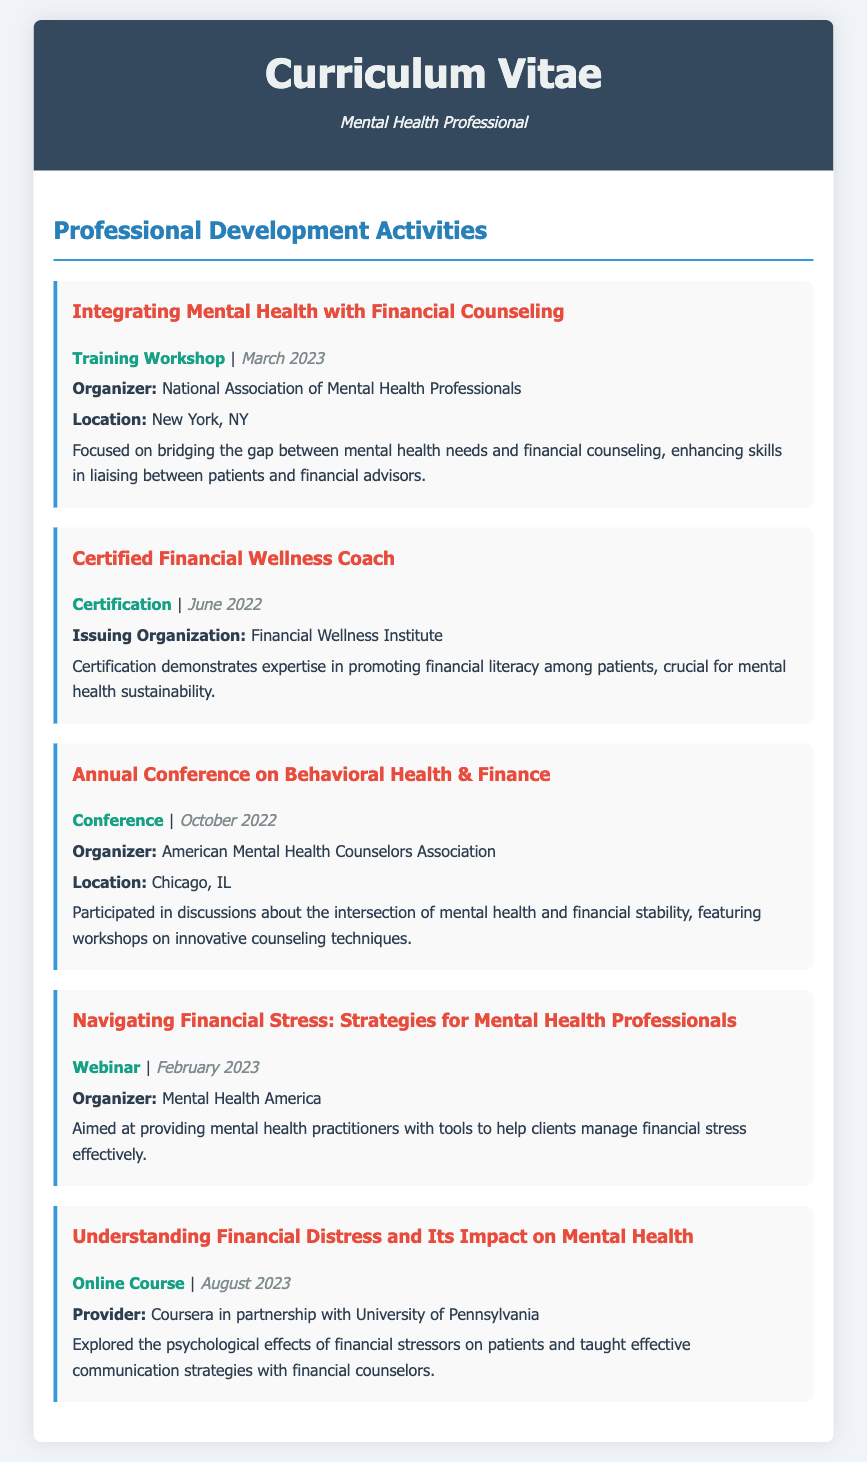what is the title of the first training workshop attended? The title is "Integrating Mental Health with Financial Counseling," which is listed first in the document.
Answer: Integrating Mental Health with Financial Counseling when did the certification for Financial Wellness Coach take place? The certification date is provided in the document as June 2022.
Answer: June 2022 who organized the Annual Conference on Behavioral Health & Finance? The organizer of the conference is mentioned as the American Mental Health Counselors Association.
Answer: American Mental Health Counselors Association what type of professional development activity is the webinar on financial stress? The document specifies that the activity type for the webinar is "Webinar."
Answer: Webinar which university partnered with Coursera for the online course? The document states that the University of Pennsylvania partnered with Coursera for the online course.
Answer: University of Pennsylvania what city hosted the Annual Conference on Behavioral Health & Finance? The document includes Chicago, IL as the location for the conference.
Answer: Chicago, IL how many professional development activities are listed in the document? The number of activities can be counted directly from the document, which lists a total of five activities.
Answer: 5 what is the focus of the training workshop held in March 2023? The document details that the focus is on bridging the gap between mental health needs and financial counseling.
Answer: Bridging the gap between mental health needs and financial counseling what skill set does the certification demonstrate? The certification demonstrates expertise in promoting financial literacy among patients.
Answer: Financial literacy what is the purpose of the webinar titled "Navigating Financial Stress"? The document describes that the webinar aims to provide mental health practitioners with tools to help clients manage financial stress effectively.
Answer: Tools to help clients manage financial stress 